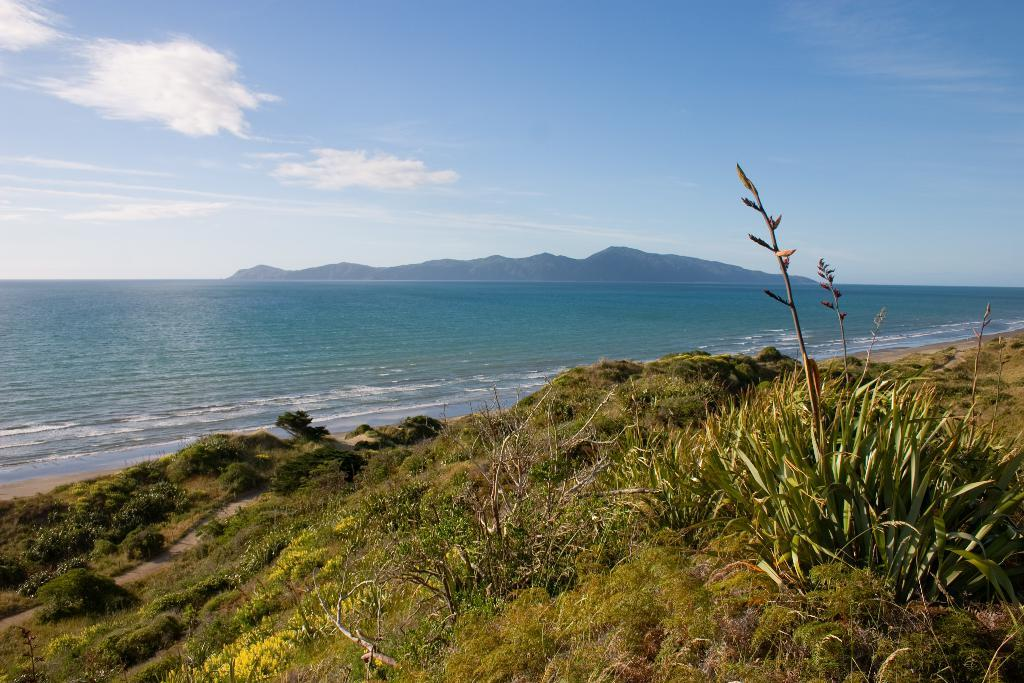What type of living organisms can be seen in the image? Plants and grass are visible in the image. What natural element can be seen in the image? There is water visible in the background of the image. What type of geographical feature is visible in the background of the image? There are hills in the background of the image. What is visible in the background of the image? The sky is visible in the background of the image. How much money is being exchanged in the image? There is no indication of any money exchange in the image. What direction are the plants facing in the image? The direction the plants are facing cannot be determined from the image. 